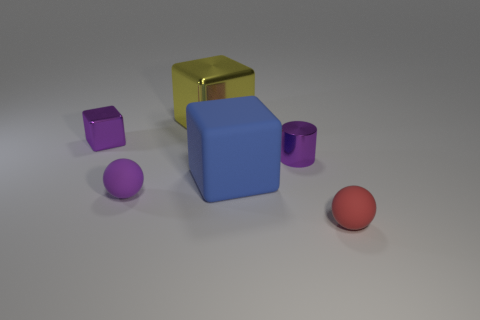Do the tiny purple shiny object that is to the left of the large matte thing and the big metal object have the same shape?
Offer a very short reply. Yes. What number of red balls are in front of the tiny thing that is to the left of the small matte thing behind the tiny red matte ball?
Provide a succinct answer. 1. Is the number of purple shiny objects behind the small purple cube less than the number of yellow blocks left of the yellow metal cube?
Provide a succinct answer. No. The other thing that is the same shape as the small red rubber object is what color?
Ensure brevity in your answer.  Purple. The yellow shiny block has what size?
Make the answer very short. Large. How many red objects are the same size as the purple block?
Provide a succinct answer. 1. Is the color of the shiny cylinder the same as the large metallic block?
Your answer should be very brief. No. Is the material of the small red ball that is in front of the large blue thing the same as the small purple thing right of the large yellow object?
Offer a very short reply. No. Is the number of green metal spheres greater than the number of purple metallic cubes?
Offer a terse response. No. Is there any other thing that has the same color as the small metal cube?
Offer a very short reply. Yes. 